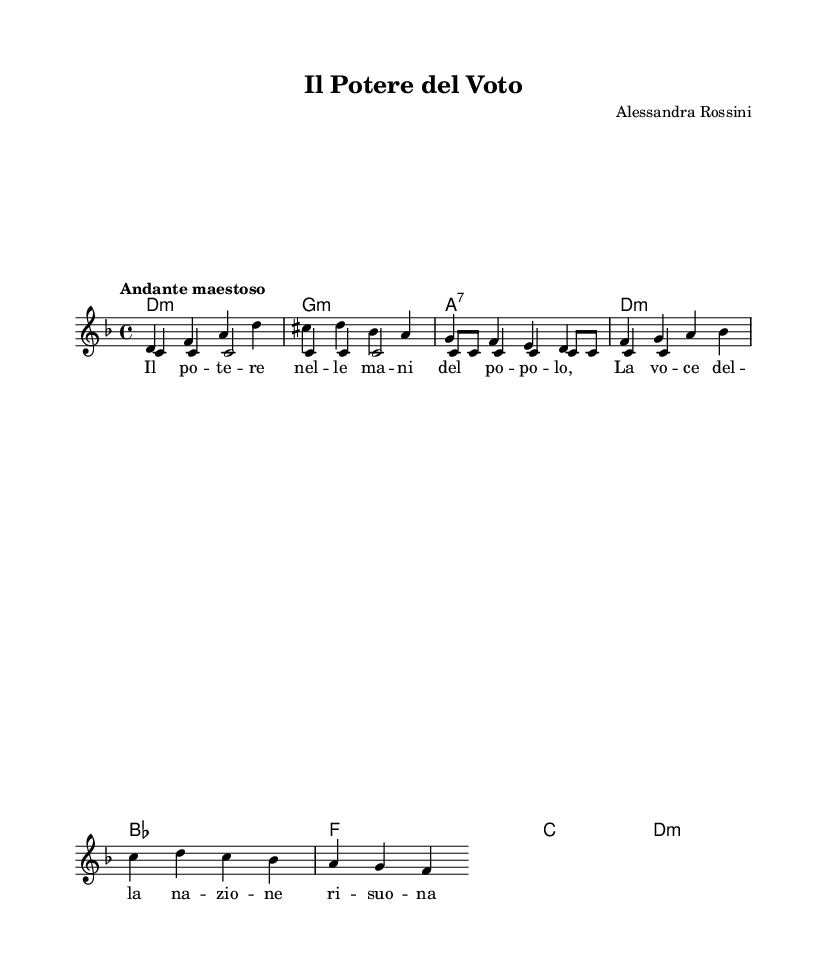What is the key signature of this music? The key signature shown in the music is D minor, which consists of one flat (B flat). This can be deduced from the global settings presented in the code.
Answer: D minor What is the time signature of this piece? The time signature is 4/4. This is indicated in the global section of the code and tells us that there are four beats per measure.
Answer: 4/4 What is the tempo indication for this piece? The tempo indication given in the score is "Andante maestoso," which suggests a moderately slow, dignified tempo. This is explicitly stated in the tempo line of the global section.
Answer: Andante maestoso What is the composer’s name? The composer mentioned in the header is Alessandra Rossini, who is credited with the creation of this piece as stated at the top of the sheet music.
Answer: Alessandra Rossini How many voices are present in the score? There are two voices indicated in the score: one for the "melody" and one for "rhythm." This can be inferred from the voice creation listed under the staff section in the code.
Answer: Two What theme appears first in the music? The first theme that appears in the music is the main theme, which is represented in the code after defining the global parameters.
Answer: Main theme What is the lyrical theme of this opera? The lyrical theme of this opera revolves around political power as described in the Italian lyrics: "Il potere nelle mani del popolo, La voce della nazione risuona." This reflects the focus on the influence of the people in power.
Answer: Political power 